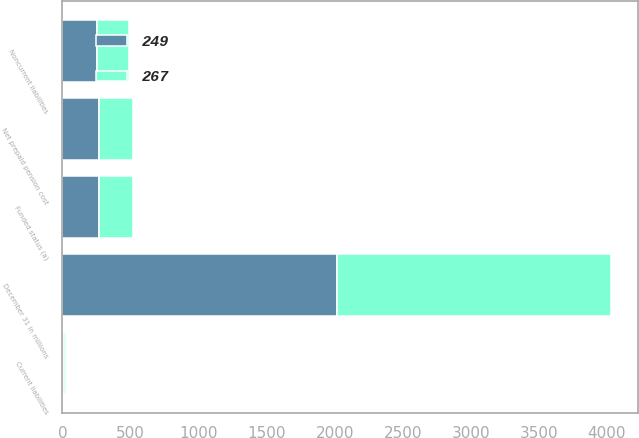Convert chart. <chart><loc_0><loc_0><loc_500><loc_500><stacked_bar_chart><ecel><fcel>December 31 in millions<fcel>Funded status (a)<fcel>Current liabilities<fcel>Noncurrent liabilities<fcel>Net prepaid pension cost<nl><fcel>249<fcel>2015<fcel>267<fcel>14<fcel>253<fcel>267<nl><fcel>267<fcel>2014<fcel>249<fcel>14<fcel>235<fcel>249<nl></chart> 